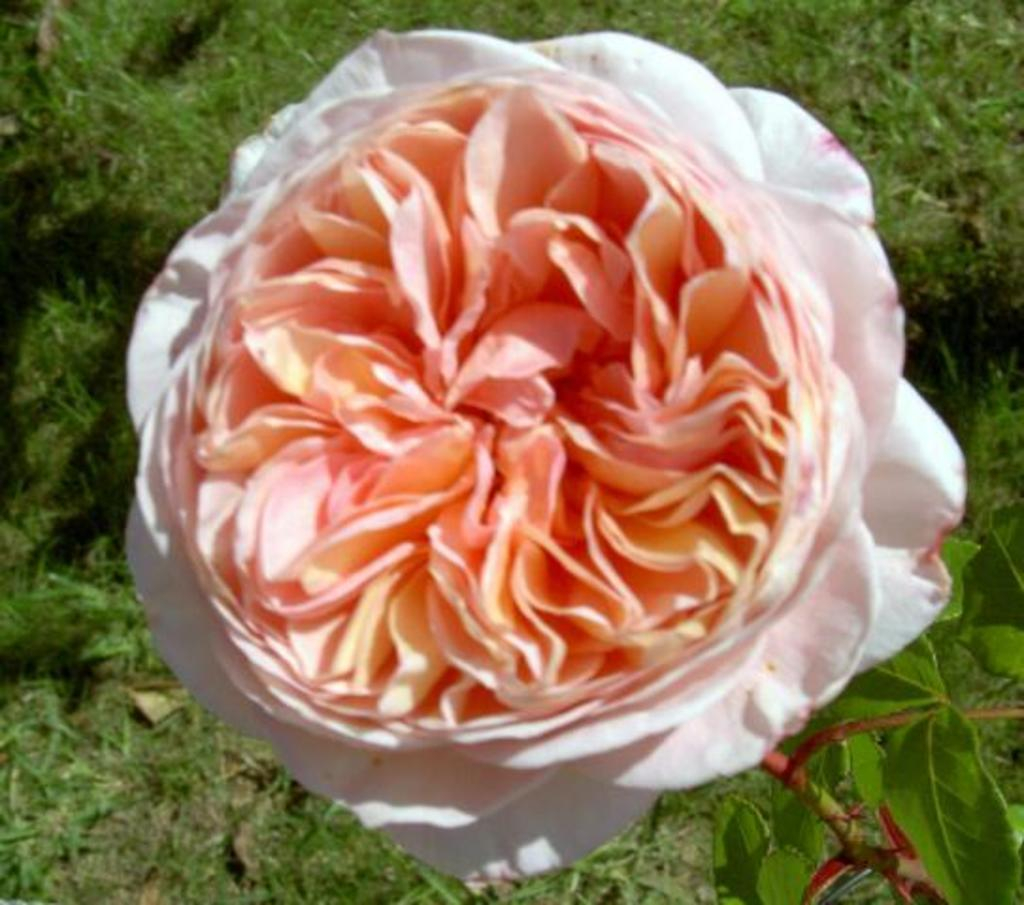What type of living organisms can be seen in the image? Plants and a flower are visible in the image. Can you describe the flower in the image? The flower is a part of the plant in the image. What type of creature is using the plants to cover itself in the image? There is no creature present in the image, and the plants are not being used to cover anything. 